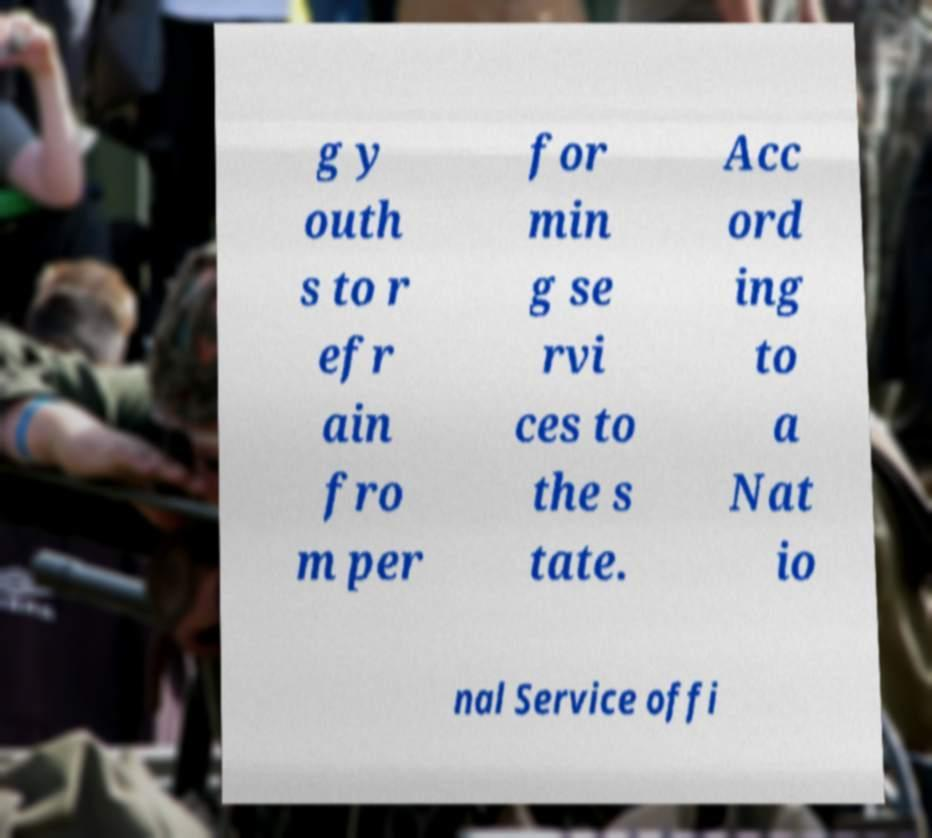Can you accurately transcribe the text from the provided image for me? g y outh s to r efr ain fro m per for min g se rvi ces to the s tate. Acc ord ing to a Nat io nal Service offi 